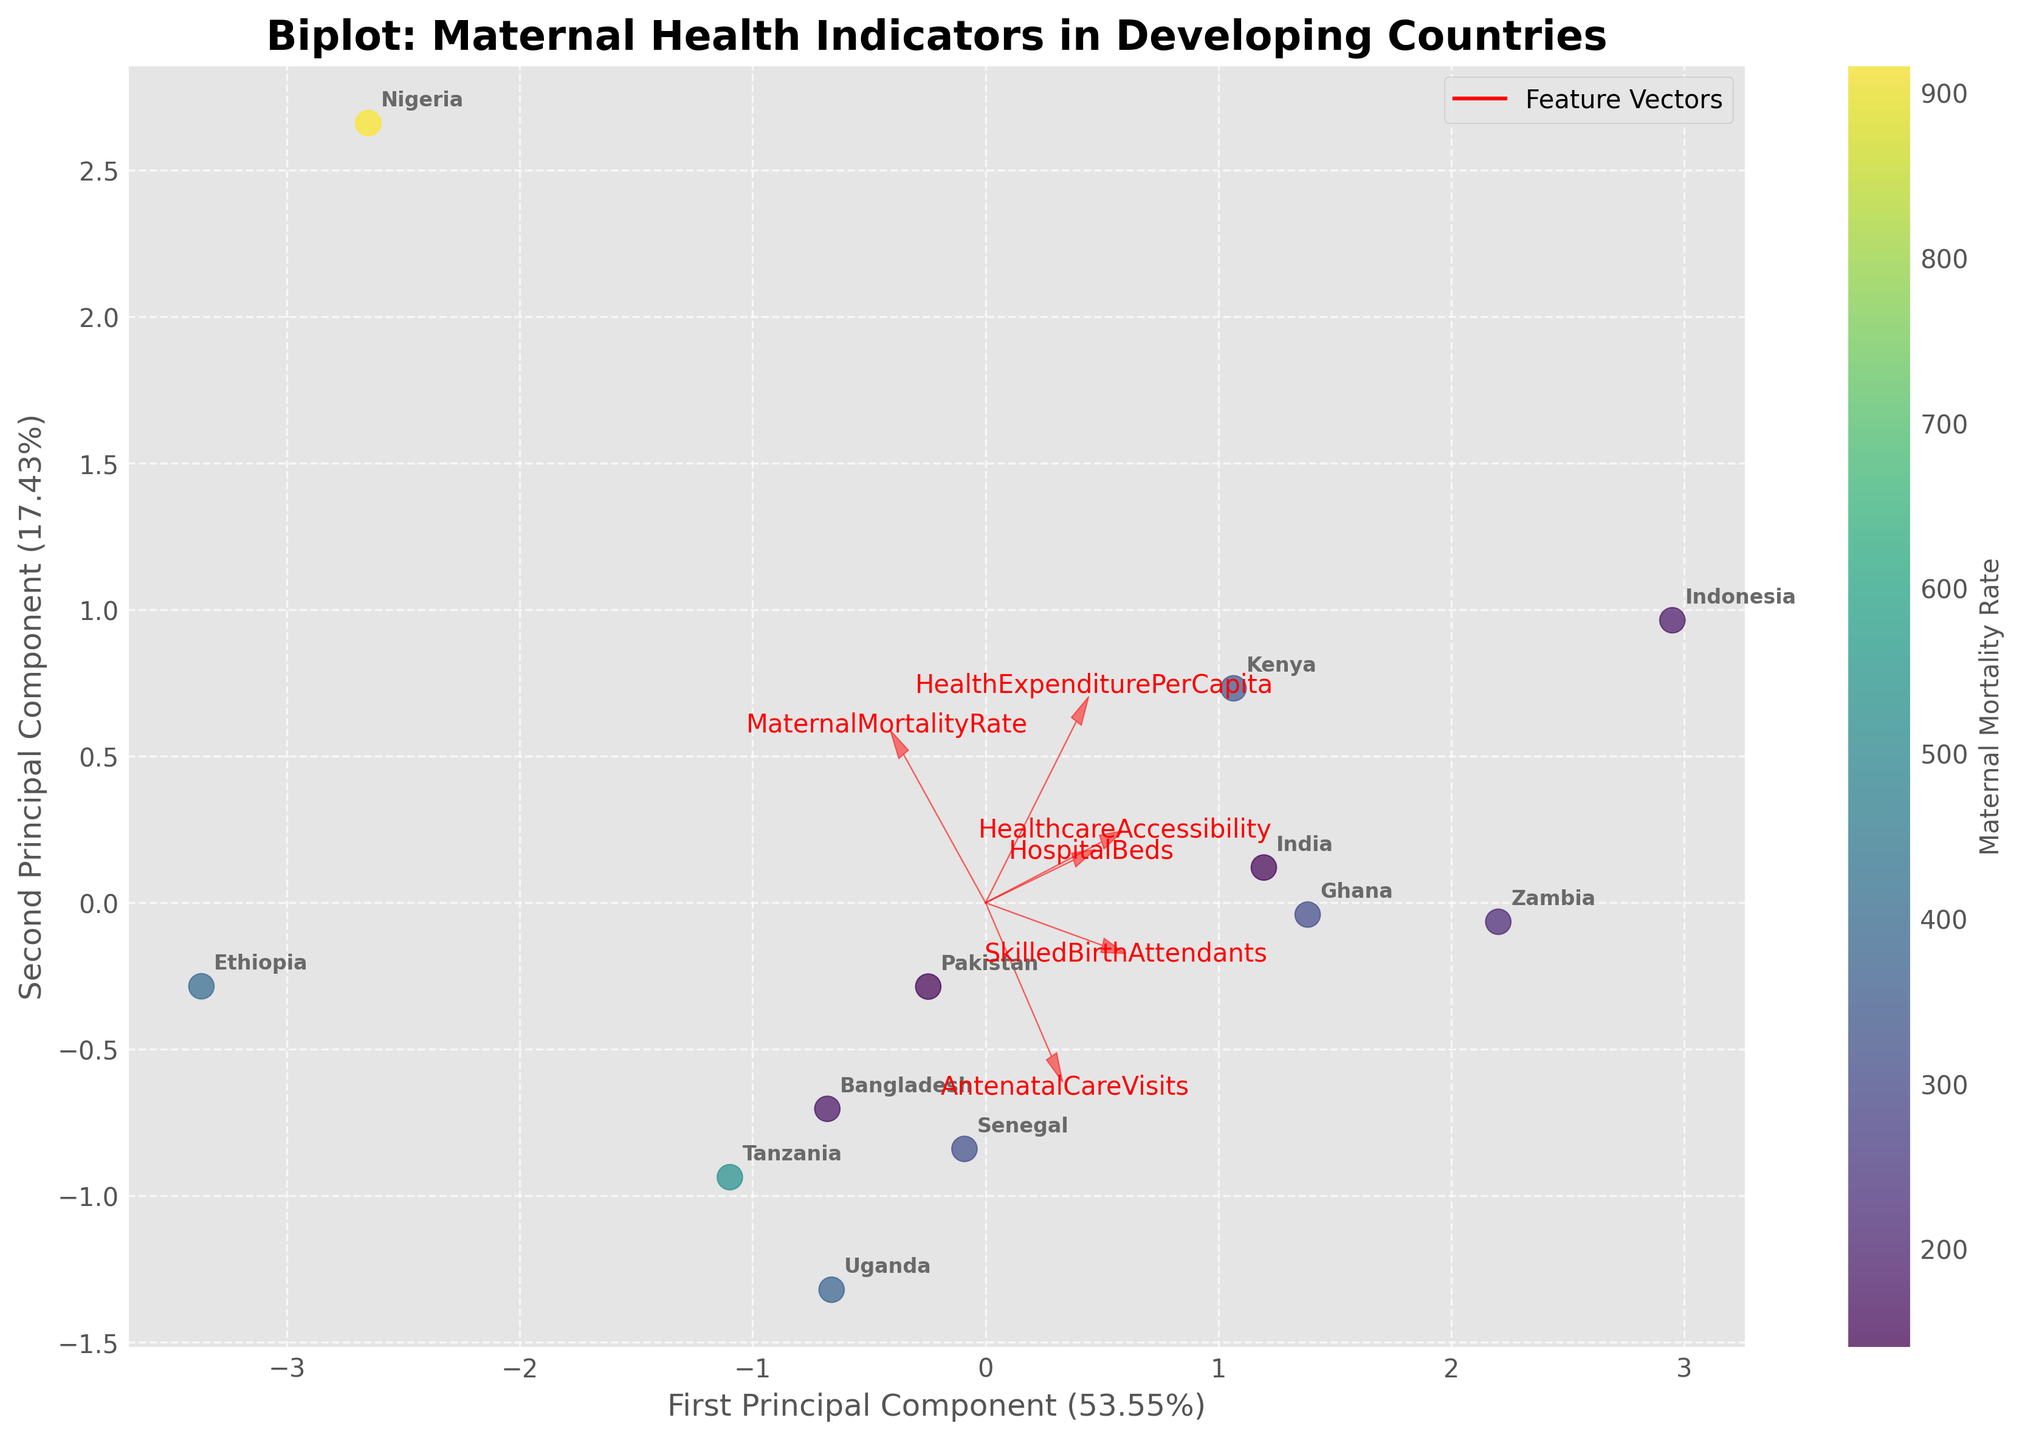What is the title of the figure? The title is displayed at the top of the plot. It reads "Biplot: Maternal Health Indicators in Developing Countries".
Answer: Biplot: Maternal Health Indicators in Developing Countries What do the x and y labels represent? The x and y labels are located on the respective axes. The x label represents the "First Principal Component", while the y label represents the "Second Principal Component".
Answer: First Principal Component, Second Principal Component Which country has the lowest Maternal Mortality Rate based on the color intensity? The color intensity of the scatter points represents the Maternal Mortality Rate. The country with the least intense (lightest) color is India.
Answer: India What are the two main features that contribute to the First Principal Component? The vectors' direction and length indicate their contributions to the principal components. The two longest vectors along the x-axis are "Maternal Mortality Rate" and "Healthcare Accessibility".
Answer: Maternal Mortality Rate, Healthcare Accessibility Which country's data point is the farthest to the right on the First Principal Component axis? By looking at the plot, the country farthest to the right of the x-axis (First Principal Component) is Kenya.
Answer: Kenya How do "Health Expenditure Per Capita" and "Hospital Beds" vectors relate to each other? By examining the plot, it can be observed that the vectors for "Health Expenditure Per Capita" and "Hospital Beds" point in similar directions, indicating a positive correlation.
Answer: Positively correlated Which country is closer to Tanzania in terms of the principal components? By checking proximity in the biplot, Uganda is the closest to Tanzania in terms of the principal components on the plot.
Answer: Uganda What do the red arrows represent in the biplot? The red arrows in the figure are feature vectors that represent the six maternal health indicators pointing in their respective directions.
Answer: Feature vectors Which two features seem to be least correlated based on their vector directions? Vectors that point in nearly opposite directions indicate features that are least correlated. "Maternal Mortality Rate" and "Skilled Birth Attendants" have vectors that point in opposite directions.
Answer: Maternal Mortality Rate and Skilled Birth Attendants What percentage of the variance is captured by the first two principal components? The labels on the axes provide the explained variance. The First Principal Component captures 50.65%, and the Second captures 26.72%. Adding these gives the total variance.
Answer: 77.37% 